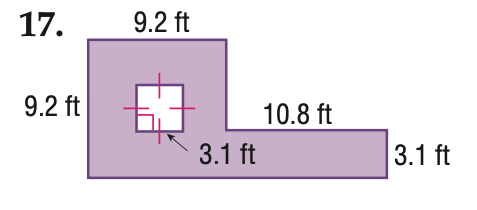Answer the mathemtical geometry problem and directly provide the correct option letter.
Question: Find the area of the shaded region. Round to the nearest tenth if necessary.
Choices: A: 75.0 B: 108.5 C: 118.1 D: 127.7 B 